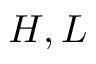Convert formula to latex. <formula><loc_0><loc_0><loc_500><loc_500>H , L</formula> 